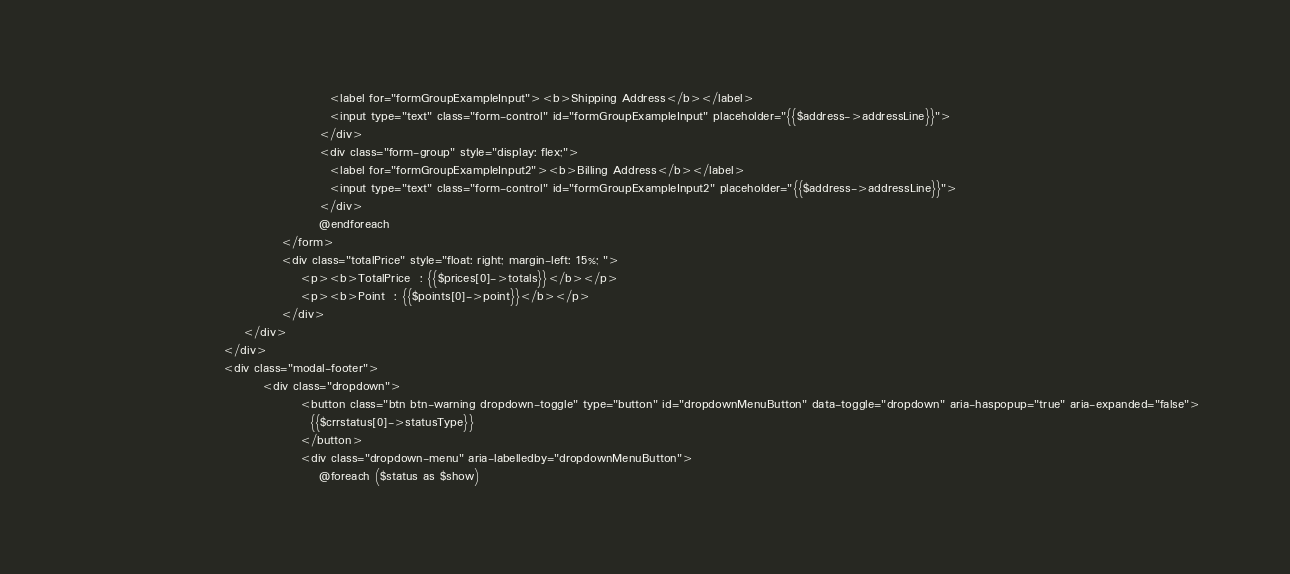Convert code to text. <code><loc_0><loc_0><loc_500><loc_500><_PHP_>                                                  <label for="formGroupExampleInput"><b>Shipping Address</b></label>
                                                  <input type="text" class="form-control" id="formGroupExampleInput" placeholder="{{$address->addressLine}}">
                                                </div>
                                                <div class="form-group" style="display: flex;">
                                                  <label for="formGroupExampleInput2"><b>Billing Address</b></label>
                                                  <input type="text" class="form-control" id="formGroupExampleInput2" placeholder="{{$address->addressLine}}">
                                                </div>
                                                @endforeach
                                        </form>
                                        <div class="totalPrice" style="float: right; margin-left: 15%; ">
                                            <p><b>TotalPrice  : {{$prices[0]->totals}}</b></p>
                                            <p><b>Point  : {{$points[0]->point}}</b></p>
                                        </div>
                                </div>
                            </div>
                            <div class="modal-footer">
                                    <div class="dropdown">
                                            <button class="btn btn-warning dropdown-toggle" type="button" id="dropdownMenuButton" data-toggle="dropdown" aria-haspopup="true" aria-expanded="false">
                                              {{$crrstatus[0]->statusType}}
                                            </button>
                                            <div class="dropdown-menu" aria-labelledby="dropdownMenuButton">
                                                @foreach ($status as $show)</code> 